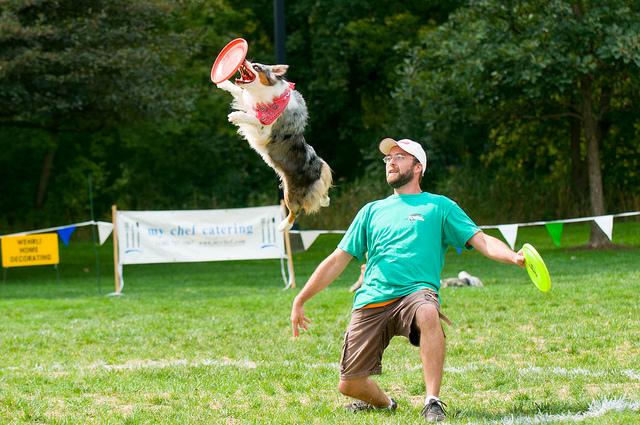Is it warm outside?
Keep it brief. Yes. What is the dog catching?
Quick response, please. Frisbee. Who is catching the flying disk?
Answer briefly. Dog. Is the dog eating a frisbee?
Keep it brief. No. 